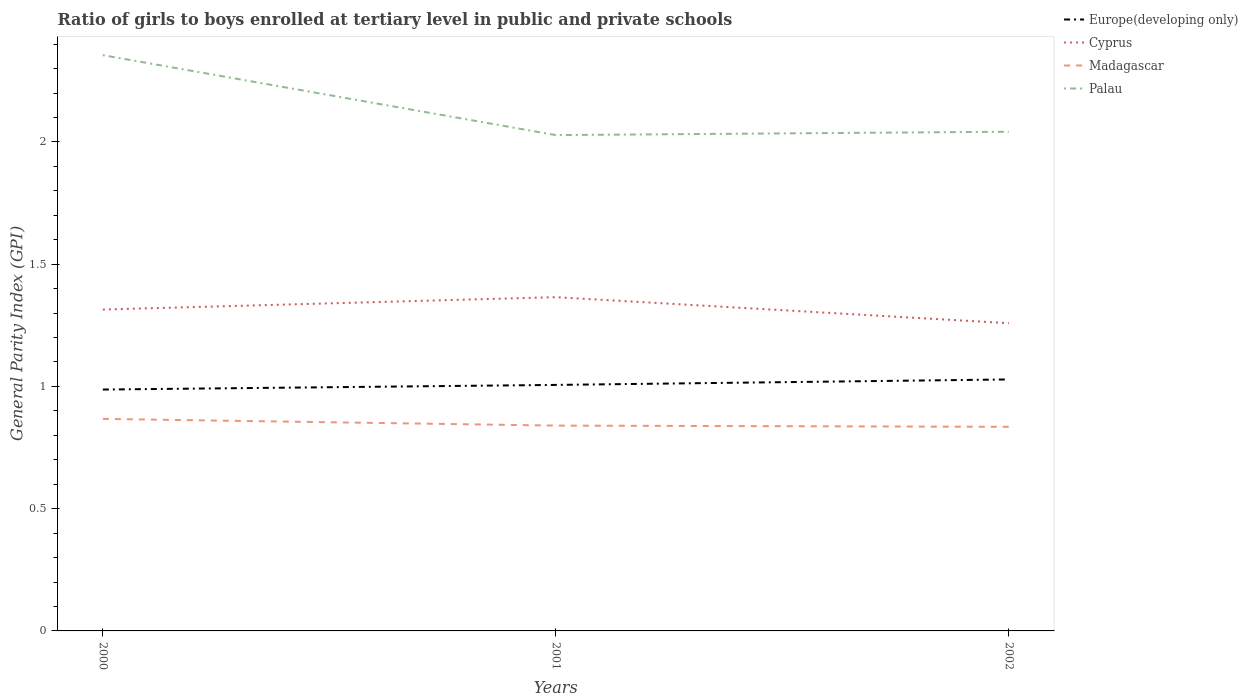Does the line corresponding to Madagascar intersect with the line corresponding to Europe(developing only)?
Your answer should be compact. No. Is the number of lines equal to the number of legend labels?
Your response must be concise. Yes. Across all years, what is the maximum general parity index in Palau?
Keep it short and to the point. 2.03. In which year was the general parity index in Palau maximum?
Make the answer very short. 2001. What is the total general parity index in Madagascar in the graph?
Your answer should be very brief. 0.03. What is the difference between the highest and the second highest general parity index in Madagascar?
Give a very brief answer. 0.03. Is the general parity index in Europe(developing only) strictly greater than the general parity index in Cyprus over the years?
Your answer should be compact. Yes. How many years are there in the graph?
Offer a terse response. 3. What is the difference between two consecutive major ticks on the Y-axis?
Make the answer very short. 0.5. Are the values on the major ticks of Y-axis written in scientific E-notation?
Ensure brevity in your answer.  No. Does the graph contain any zero values?
Your answer should be compact. No. Does the graph contain grids?
Keep it short and to the point. No. Where does the legend appear in the graph?
Provide a short and direct response. Top right. What is the title of the graph?
Offer a very short reply. Ratio of girls to boys enrolled at tertiary level in public and private schools. Does "Bolivia" appear as one of the legend labels in the graph?
Your answer should be compact. No. What is the label or title of the X-axis?
Make the answer very short. Years. What is the label or title of the Y-axis?
Keep it short and to the point. General Parity Index (GPI). What is the General Parity Index (GPI) in Europe(developing only) in 2000?
Your response must be concise. 0.99. What is the General Parity Index (GPI) in Cyprus in 2000?
Ensure brevity in your answer.  1.31. What is the General Parity Index (GPI) in Madagascar in 2000?
Give a very brief answer. 0.87. What is the General Parity Index (GPI) in Palau in 2000?
Your response must be concise. 2.35. What is the General Parity Index (GPI) in Europe(developing only) in 2001?
Give a very brief answer. 1.01. What is the General Parity Index (GPI) in Cyprus in 2001?
Ensure brevity in your answer.  1.37. What is the General Parity Index (GPI) in Madagascar in 2001?
Offer a very short reply. 0.84. What is the General Parity Index (GPI) in Palau in 2001?
Make the answer very short. 2.03. What is the General Parity Index (GPI) in Europe(developing only) in 2002?
Give a very brief answer. 1.03. What is the General Parity Index (GPI) of Cyprus in 2002?
Provide a succinct answer. 1.26. What is the General Parity Index (GPI) of Madagascar in 2002?
Your answer should be compact. 0.83. What is the General Parity Index (GPI) in Palau in 2002?
Ensure brevity in your answer.  2.04. Across all years, what is the maximum General Parity Index (GPI) of Europe(developing only)?
Ensure brevity in your answer.  1.03. Across all years, what is the maximum General Parity Index (GPI) in Cyprus?
Offer a very short reply. 1.37. Across all years, what is the maximum General Parity Index (GPI) in Madagascar?
Keep it short and to the point. 0.87. Across all years, what is the maximum General Parity Index (GPI) in Palau?
Make the answer very short. 2.35. Across all years, what is the minimum General Parity Index (GPI) of Europe(developing only)?
Your response must be concise. 0.99. Across all years, what is the minimum General Parity Index (GPI) of Cyprus?
Your response must be concise. 1.26. Across all years, what is the minimum General Parity Index (GPI) of Madagascar?
Provide a succinct answer. 0.83. Across all years, what is the minimum General Parity Index (GPI) in Palau?
Give a very brief answer. 2.03. What is the total General Parity Index (GPI) of Europe(developing only) in the graph?
Give a very brief answer. 3.02. What is the total General Parity Index (GPI) in Cyprus in the graph?
Make the answer very short. 3.94. What is the total General Parity Index (GPI) in Madagascar in the graph?
Your answer should be very brief. 2.54. What is the total General Parity Index (GPI) in Palau in the graph?
Your answer should be very brief. 6.42. What is the difference between the General Parity Index (GPI) in Europe(developing only) in 2000 and that in 2001?
Offer a terse response. -0.02. What is the difference between the General Parity Index (GPI) of Cyprus in 2000 and that in 2001?
Your answer should be very brief. -0.05. What is the difference between the General Parity Index (GPI) of Madagascar in 2000 and that in 2001?
Provide a succinct answer. 0.03. What is the difference between the General Parity Index (GPI) in Palau in 2000 and that in 2001?
Make the answer very short. 0.33. What is the difference between the General Parity Index (GPI) in Europe(developing only) in 2000 and that in 2002?
Give a very brief answer. -0.04. What is the difference between the General Parity Index (GPI) in Cyprus in 2000 and that in 2002?
Keep it short and to the point. 0.06. What is the difference between the General Parity Index (GPI) in Madagascar in 2000 and that in 2002?
Your answer should be compact. 0.03. What is the difference between the General Parity Index (GPI) of Palau in 2000 and that in 2002?
Offer a very short reply. 0.31. What is the difference between the General Parity Index (GPI) of Europe(developing only) in 2001 and that in 2002?
Your answer should be compact. -0.02. What is the difference between the General Parity Index (GPI) in Cyprus in 2001 and that in 2002?
Offer a terse response. 0.11. What is the difference between the General Parity Index (GPI) in Madagascar in 2001 and that in 2002?
Ensure brevity in your answer.  0.01. What is the difference between the General Parity Index (GPI) in Palau in 2001 and that in 2002?
Offer a very short reply. -0.01. What is the difference between the General Parity Index (GPI) of Europe(developing only) in 2000 and the General Parity Index (GPI) of Cyprus in 2001?
Keep it short and to the point. -0.38. What is the difference between the General Parity Index (GPI) of Europe(developing only) in 2000 and the General Parity Index (GPI) of Madagascar in 2001?
Keep it short and to the point. 0.15. What is the difference between the General Parity Index (GPI) of Europe(developing only) in 2000 and the General Parity Index (GPI) of Palau in 2001?
Your response must be concise. -1.04. What is the difference between the General Parity Index (GPI) of Cyprus in 2000 and the General Parity Index (GPI) of Madagascar in 2001?
Your answer should be compact. 0.47. What is the difference between the General Parity Index (GPI) in Cyprus in 2000 and the General Parity Index (GPI) in Palau in 2001?
Your answer should be very brief. -0.71. What is the difference between the General Parity Index (GPI) of Madagascar in 2000 and the General Parity Index (GPI) of Palau in 2001?
Offer a very short reply. -1.16. What is the difference between the General Parity Index (GPI) of Europe(developing only) in 2000 and the General Parity Index (GPI) of Cyprus in 2002?
Your answer should be very brief. -0.27. What is the difference between the General Parity Index (GPI) in Europe(developing only) in 2000 and the General Parity Index (GPI) in Madagascar in 2002?
Your answer should be very brief. 0.15. What is the difference between the General Parity Index (GPI) in Europe(developing only) in 2000 and the General Parity Index (GPI) in Palau in 2002?
Make the answer very short. -1.05. What is the difference between the General Parity Index (GPI) in Cyprus in 2000 and the General Parity Index (GPI) in Madagascar in 2002?
Provide a short and direct response. 0.48. What is the difference between the General Parity Index (GPI) in Cyprus in 2000 and the General Parity Index (GPI) in Palau in 2002?
Offer a terse response. -0.73. What is the difference between the General Parity Index (GPI) of Madagascar in 2000 and the General Parity Index (GPI) of Palau in 2002?
Your answer should be compact. -1.17. What is the difference between the General Parity Index (GPI) in Europe(developing only) in 2001 and the General Parity Index (GPI) in Cyprus in 2002?
Offer a terse response. -0.25. What is the difference between the General Parity Index (GPI) of Europe(developing only) in 2001 and the General Parity Index (GPI) of Madagascar in 2002?
Offer a terse response. 0.17. What is the difference between the General Parity Index (GPI) of Europe(developing only) in 2001 and the General Parity Index (GPI) of Palau in 2002?
Your response must be concise. -1.04. What is the difference between the General Parity Index (GPI) in Cyprus in 2001 and the General Parity Index (GPI) in Madagascar in 2002?
Provide a short and direct response. 0.53. What is the difference between the General Parity Index (GPI) of Cyprus in 2001 and the General Parity Index (GPI) of Palau in 2002?
Your response must be concise. -0.68. What is the difference between the General Parity Index (GPI) of Madagascar in 2001 and the General Parity Index (GPI) of Palau in 2002?
Offer a terse response. -1.2. What is the average General Parity Index (GPI) of Europe(developing only) per year?
Offer a terse response. 1.01. What is the average General Parity Index (GPI) of Cyprus per year?
Give a very brief answer. 1.31. What is the average General Parity Index (GPI) in Madagascar per year?
Your answer should be very brief. 0.85. What is the average General Parity Index (GPI) of Palau per year?
Your answer should be very brief. 2.14. In the year 2000, what is the difference between the General Parity Index (GPI) of Europe(developing only) and General Parity Index (GPI) of Cyprus?
Offer a terse response. -0.33. In the year 2000, what is the difference between the General Parity Index (GPI) of Europe(developing only) and General Parity Index (GPI) of Madagascar?
Make the answer very short. 0.12. In the year 2000, what is the difference between the General Parity Index (GPI) of Europe(developing only) and General Parity Index (GPI) of Palau?
Offer a terse response. -1.37. In the year 2000, what is the difference between the General Parity Index (GPI) of Cyprus and General Parity Index (GPI) of Madagascar?
Ensure brevity in your answer.  0.45. In the year 2000, what is the difference between the General Parity Index (GPI) in Cyprus and General Parity Index (GPI) in Palau?
Your answer should be compact. -1.04. In the year 2000, what is the difference between the General Parity Index (GPI) in Madagascar and General Parity Index (GPI) in Palau?
Provide a succinct answer. -1.49. In the year 2001, what is the difference between the General Parity Index (GPI) of Europe(developing only) and General Parity Index (GPI) of Cyprus?
Provide a succinct answer. -0.36. In the year 2001, what is the difference between the General Parity Index (GPI) of Europe(developing only) and General Parity Index (GPI) of Madagascar?
Give a very brief answer. 0.17. In the year 2001, what is the difference between the General Parity Index (GPI) in Europe(developing only) and General Parity Index (GPI) in Palau?
Your answer should be very brief. -1.02. In the year 2001, what is the difference between the General Parity Index (GPI) of Cyprus and General Parity Index (GPI) of Madagascar?
Ensure brevity in your answer.  0.53. In the year 2001, what is the difference between the General Parity Index (GPI) in Cyprus and General Parity Index (GPI) in Palau?
Keep it short and to the point. -0.66. In the year 2001, what is the difference between the General Parity Index (GPI) in Madagascar and General Parity Index (GPI) in Palau?
Provide a short and direct response. -1.19. In the year 2002, what is the difference between the General Parity Index (GPI) in Europe(developing only) and General Parity Index (GPI) in Cyprus?
Provide a succinct answer. -0.23. In the year 2002, what is the difference between the General Parity Index (GPI) in Europe(developing only) and General Parity Index (GPI) in Madagascar?
Your answer should be compact. 0.19. In the year 2002, what is the difference between the General Parity Index (GPI) of Europe(developing only) and General Parity Index (GPI) of Palau?
Offer a terse response. -1.01. In the year 2002, what is the difference between the General Parity Index (GPI) in Cyprus and General Parity Index (GPI) in Madagascar?
Make the answer very short. 0.42. In the year 2002, what is the difference between the General Parity Index (GPI) of Cyprus and General Parity Index (GPI) of Palau?
Ensure brevity in your answer.  -0.78. In the year 2002, what is the difference between the General Parity Index (GPI) of Madagascar and General Parity Index (GPI) of Palau?
Your answer should be compact. -1.21. What is the ratio of the General Parity Index (GPI) in Europe(developing only) in 2000 to that in 2001?
Your answer should be very brief. 0.98. What is the ratio of the General Parity Index (GPI) in Cyprus in 2000 to that in 2001?
Your answer should be compact. 0.96. What is the ratio of the General Parity Index (GPI) in Madagascar in 2000 to that in 2001?
Keep it short and to the point. 1.03. What is the ratio of the General Parity Index (GPI) of Palau in 2000 to that in 2001?
Your answer should be compact. 1.16. What is the ratio of the General Parity Index (GPI) in Europe(developing only) in 2000 to that in 2002?
Keep it short and to the point. 0.96. What is the ratio of the General Parity Index (GPI) in Cyprus in 2000 to that in 2002?
Provide a succinct answer. 1.04. What is the ratio of the General Parity Index (GPI) in Madagascar in 2000 to that in 2002?
Ensure brevity in your answer.  1.04. What is the ratio of the General Parity Index (GPI) of Palau in 2000 to that in 2002?
Your response must be concise. 1.15. What is the ratio of the General Parity Index (GPI) of Europe(developing only) in 2001 to that in 2002?
Your response must be concise. 0.98. What is the ratio of the General Parity Index (GPI) of Cyprus in 2001 to that in 2002?
Give a very brief answer. 1.08. What is the ratio of the General Parity Index (GPI) in Palau in 2001 to that in 2002?
Your answer should be compact. 0.99. What is the difference between the highest and the second highest General Parity Index (GPI) of Europe(developing only)?
Give a very brief answer. 0.02. What is the difference between the highest and the second highest General Parity Index (GPI) in Cyprus?
Your answer should be very brief. 0.05. What is the difference between the highest and the second highest General Parity Index (GPI) of Madagascar?
Keep it short and to the point. 0.03. What is the difference between the highest and the second highest General Parity Index (GPI) of Palau?
Offer a terse response. 0.31. What is the difference between the highest and the lowest General Parity Index (GPI) in Europe(developing only)?
Provide a short and direct response. 0.04. What is the difference between the highest and the lowest General Parity Index (GPI) in Cyprus?
Your answer should be compact. 0.11. What is the difference between the highest and the lowest General Parity Index (GPI) in Madagascar?
Give a very brief answer. 0.03. What is the difference between the highest and the lowest General Parity Index (GPI) in Palau?
Provide a succinct answer. 0.33. 